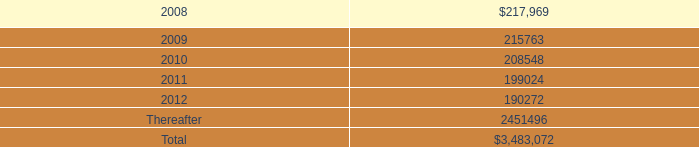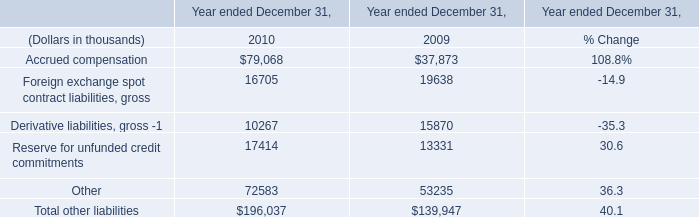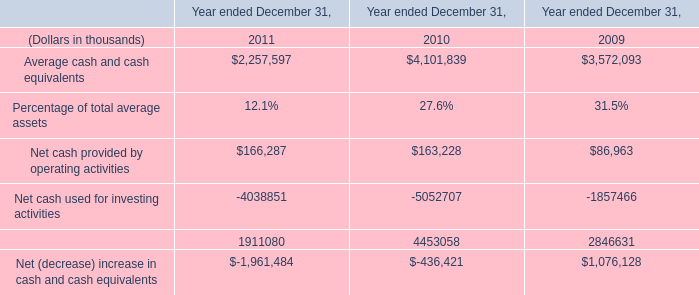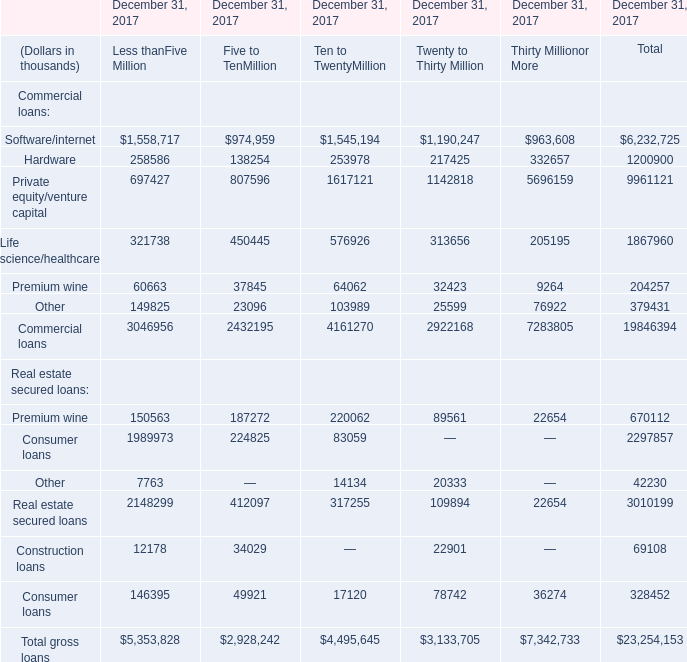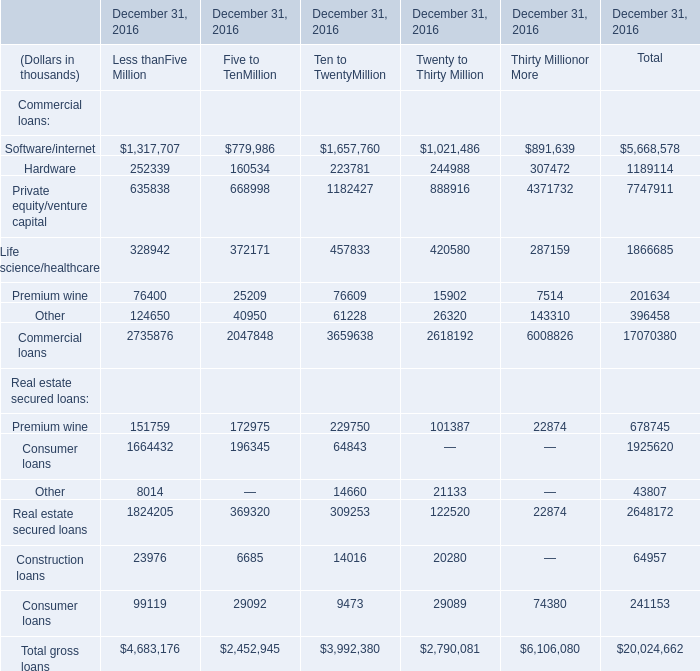what is the percentage change in aggregate rent expense from 2006 to 2007? 
Computations: ((246.4 - 237.0) / 237.0)
Answer: 0.03966. 